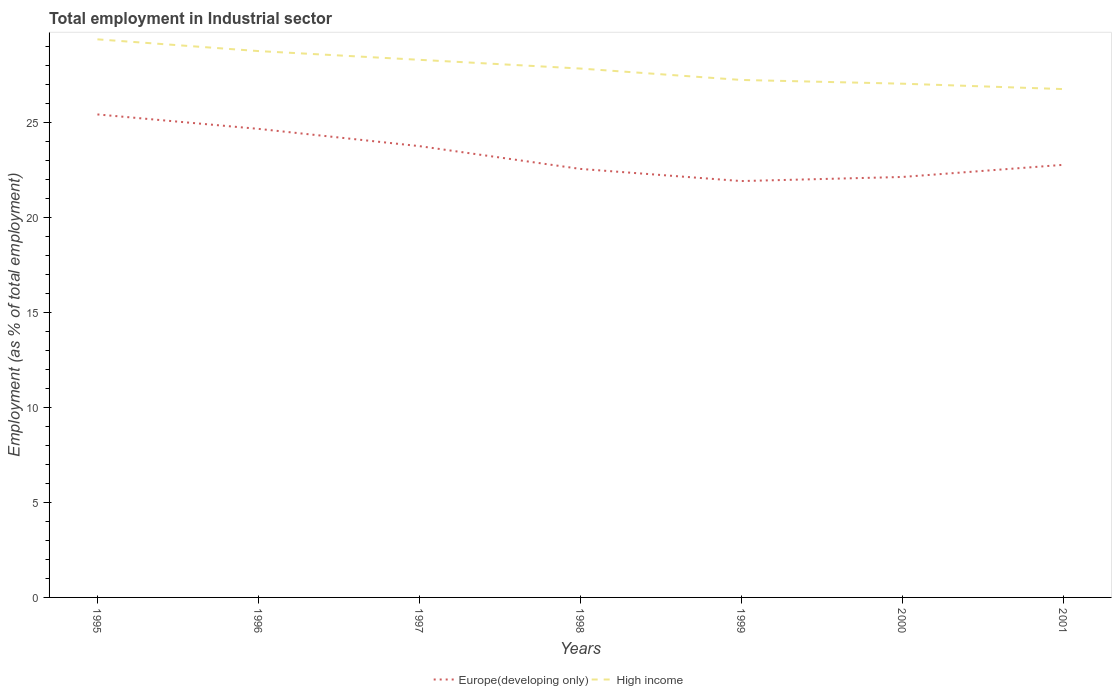Does the line corresponding to High income intersect with the line corresponding to Europe(developing only)?
Offer a very short reply. No. Is the number of lines equal to the number of legend labels?
Your response must be concise. Yes. Across all years, what is the maximum employment in industrial sector in Europe(developing only)?
Your answer should be compact. 21.93. What is the total employment in industrial sector in High income in the graph?
Offer a terse response. 0.6. What is the difference between the highest and the second highest employment in industrial sector in Europe(developing only)?
Keep it short and to the point. 3.51. What is the difference between the highest and the lowest employment in industrial sector in Europe(developing only)?
Your answer should be very brief. 3. Is the employment in industrial sector in High income strictly greater than the employment in industrial sector in Europe(developing only) over the years?
Keep it short and to the point. No. How many years are there in the graph?
Ensure brevity in your answer.  7. Are the values on the major ticks of Y-axis written in scientific E-notation?
Offer a terse response. No. Where does the legend appear in the graph?
Give a very brief answer. Bottom center. How are the legend labels stacked?
Make the answer very short. Horizontal. What is the title of the graph?
Offer a terse response. Total employment in Industrial sector. Does "New Caledonia" appear as one of the legend labels in the graph?
Your answer should be compact. No. What is the label or title of the X-axis?
Keep it short and to the point. Years. What is the label or title of the Y-axis?
Ensure brevity in your answer.  Employment (as % of total employment). What is the Employment (as % of total employment) in Europe(developing only) in 1995?
Your answer should be compact. 25.44. What is the Employment (as % of total employment) of High income in 1995?
Provide a short and direct response. 29.4. What is the Employment (as % of total employment) of Europe(developing only) in 1996?
Your answer should be very brief. 24.68. What is the Employment (as % of total employment) in High income in 1996?
Your answer should be compact. 28.78. What is the Employment (as % of total employment) of Europe(developing only) in 1997?
Ensure brevity in your answer.  23.77. What is the Employment (as % of total employment) in High income in 1997?
Your answer should be very brief. 28.32. What is the Employment (as % of total employment) in Europe(developing only) in 1998?
Offer a terse response. 22.57. What is the Employment (as % of total employment) of High income in 1998?
Your answer should be compact. 27.86. What is the Employment (as % of total employment) in Europe(developing only) in 1999?
Provide a succinct answer. 21.93. What is the Employment (as % of total employment) in High income in 1999?
Give a very brief answer. 27.26. What is the Employment (as % of total employment) of Europe(developing only) in 2000?
Provide a short and direct response. 22.15. What is the Employment (as % of total employment) of High income in 2000?
Keep it short and to the point. 27.06. What is the Employment (as % of total employment) of Europe(developing only) in 2001?
Provide a succinct answer. 22.79. What is the Employment (as % of total employment) in High income in 2001?
Make the answer very short. 26.78. Across all years, what is the maximum Employment (as % of total employment) in Europe(developing only)?
Ensure brevity in your answer.  25.44. Across all years, what is the maximum Employment (as % of total employment) of High income?
Your response must be concise. 29.4. Across all years, what is the minimum Employment (as % of total employment) in Europe(developing only)?
Offer a terse response. 21.93. Across all years, what is the minimum Employment (as % of total employment) of High income?
Your response must be concise. 26.78. What is the total Employment (as % of total employment) in Europe(developing only) in the graph?
Your answer should be compact. 163.33. What is the total Employment (as % of total employment) in High income in the graph?
Provide a short and direct response. 195.45. What is the difference between the Employment (as % of total employment) of Europe(developing only) in 1995 and that in 1996?
Give a very brief answer. 0.76. What is the difference between the Employment (as % of total employment) of High income in 1995 and that in 1996?
Your answer should be very brief. 0.62. What is the difference between the Employment (as % of total employment) of Europe(developing only) in 1995 and that in 1997?
Make the answer very short. 1.67. What is the difference between the Employment (as % of total employment) in High income in 1995 and that in 1997?
Make the answer very short. 1.08. What is the difference between the Employment (as % of total employment) of Europe(developing only) in 1995 and that in 1998?
Keep it short and to the point. 2.87. What is the difference between the Employment (as % of total employment) in High income in 1995 and that in 1998?
Ensure brevity in your answer.  1.54. What is the difference between the Employment (as % of total employment) in Europe(developing only) in 1995 and that in 1999?
Your response must be concise. 3.51. What is the difference between the Employment (as % of total employment) of High income in 1995 and that in 1999?
Your response must be concise. 2.14. What is the difference between the Employment (as % of total employment) in Europe(developing only) in 1995 and that in 2000?
Keep it short and to the point. 3.29. What is the difference between the Employment (as % of total employment) of High income in 1995 and that in 2000?
Your answer should be compact. 2.34. What is the difference between the Employment (as % of total employment) of Europe(developing only) in 1995 and that in 2001?
Provide a succinct answer. 2.66. What is the difference between the Employment (as % of total employment) in High income in 1995 and that in 2001?
Make the answer very short. 2.62. What is the difference between the Employment (as % of total employment) in Europe(developing only) in 1996 and that in 1997?
Your answer should be very brief. 0.91. What is the difference between the Employment (as % of total employment) in High income in 1996 and that in 1997?
Provide a short and direct response. 0.46. What is the difference between the Employment (as % of total employment) in Europe(developing only) in 1996 and that in 1998?
Give a very brief answer. 2.11. What is the difference between the Employment (as % of total employment) in High income in 1996 and that in 1998?
Offer a terse response. 0.92. What is the difference between the Employment (as % of total employment) of Europe(developing only) in 1996 and that in 1999?
Keep it short and to the point. 2.75. What is the difference between the Employment (as % of total employment) of High income in 1996 and that in 1999?
Offer a terse response. 1.52. What is the difference between the Employment (as % of total employment) in Europe(developing only) in 1996 and that in 2000?
Offer a very short reply. 2.53. What is the difference between the Employment (as % of total employment) in High income in 1996 and that in 2000?
Offer a very short reply. 1.72. What is the difference between the Employment (as % of total employment) in Europe(developing only) in 1996 and that in 2001?
Give a very brief answer. 1.89. What is the difference between the Employment (as % of total employment) in High income in 1996 and that in 2001?
Your response must be concise. 2. What is the difference between the Employment (as % of total employment) in High income in 1997 and that in 1998?
Offer a very short reply. 0.46. What is the difference between the Employment (as % of total employment) of Europe(developing only) in 1997 and that in 1999?
Offer a terse response. 1.84. What is the difference between the Employment (as % of total employment) of High income in 1997 and that in 1999?
Make the answer very short. 1.06. What is the difference between the Employment (as % of total employment) of Europe(developing only) in 1997 and that in 2000?
Ensure brevity in your answer.  1.62. What is the difference between the Employment (as % of total employment) of High income in 1997 and that in 2000?
Provide a short and direct response. 1.26. What is the difference between the Employment (as % of total employment) in Europe(developing only) in 1997 and that in 2001?
Make the answer very short. 0.99. What is the difference between the Employment (as % of total employment) in High income in 1997 and that in 2001?
Make the answer very short. 1.54. What is the difference between the Employment (as % of total employment) in Europe(developing only) in 1998 and that in 1999?
Your answer should be very brief. 0.64. What is the difference between the Employment (as % of total employment) of High income in 1998 and that in 1999?
Offer a very short reply. 0.6. What is the difference between the Employment (as % of total employment) in Europe(developing only) in 1998 and that in 2000?
Make the answer very short. 0.42. What is the difference between the Employment (as % of total employment) in High income in 1998 and that in 2000?
Provide a short and direct response. 0.8. What is the difference between the Employment (as % of total employment) in Europe(developing only) in 1998 and that in 2001?
Your response must be concise. -0.21. What is the difference between the Employment (as % of total employment) in High income in 1998 and that in 2001?
Your response must be concise. 1.08. What is the difference between the Employment (as % of total employment) in Europe(developing only) in 1999 and that in 2000?
Make the answer very short. -0.22. What is the difference between the Employment (as % of total employment) in High income in 1999 and that in 2000?
Your response must be concise. 0.2. What is the difference between the Employment (as % of total employment) of Europe(developing only) in 1999 and that in 2001?
Give a very brief answer. -0.85. What is the difference between the Employment (as % of total employment) of High income in 1999 and that in 2001?
Your answer should be very brief. 0.48. What is the difference between the Employment (as % of total employment) of Europe(developing only) in 2000 and that in 2001?
Offer a very short reply. -0.64. What is the difference between the Employment (as % of total employment) of High income in 2000 and that in 2001?
Offer a very short reply. 0.28. What is the difference between the Employment (as % of total employment) of Europe(developing only) in 1995 and the Employment (as % of total employment) of High income in 1996?
Ensure brevity in your answer.  -3.34. What is the difference between the Employment (as % of total employment) of Europe(developing only) in 1995 and the Employment (as % of total employment) of High income in 1997?
Your answer should be compact. -2.88. What is the difference between the Employment (as % of total employment) in Europe(developing only) in 1995 and the Employment (as % of total employment) in High income in 1998?
Provide a short and direct response. -2.42. What is the difference between the Employment (as % of total employment) of Europe(developing only) in 1995 and the Employment (as % of total employment) of High income in 1999?
Keep it short and to the point. -1.82. What is the difference between the Employment (as % of total employment) of Europe(developing only) in 1995 and the Employment (as % of total employment) of High income in 2000?
Make the answer very short. -1.62. What is the difference between the Employment (as % of total employment) in Europe(developing only) in 1995 and the Employment (as % of total employment) in High income in 2001?
Your answer should be compact. -1.33. What is the difference between the Employment (as % of total employment) of Europe(developing only) in 1996 and the Employment (as % of total employment) of High income in 1997?
Your response must be concise. -3.64. What is the difference between the Employment (as % of total employment) in Europe(developing only) in 1996 and the Employment (as % of total employment) in High income in 1998?
Provide a short and direct response. -3.18. What is the difference between the Employment (as % of total employment) in Europe(developing only) in 1996 and the Employment (as % of total employment) in High income in 1999?
Offer a very short reply. -2.58. What is the difference between the Employment (as % of total employment) in Europe(developing only) in 1996 and the Employment (as % of total employment) in High income in 2000?
Offer a terse response. -2.38. What is the difference between the Employment (as % of total employment) of Europe(developing only) in 1996 and the Employment (as % of total employment) of High income in 2001?
Provide a short and direct response. -2.1. What is the difference between the Employment (as % of total employment) in Europe(developing only) in 1997 and the Employment (as % of total employment) in High income in 1998?
Ensure brevity in your answer.  -4.09. What is the difference between the Employment (as % of total employment) of Europe(developing only) in 1997 and the Employment (as % of total employment) of High income in 1999?
Make the answer very short. -3.49. What is the difference between the Employment (as % of total employment) of Europe(developing only) in 1997 and the Employment (as % of total employment) of High income in 2000?
Offer a very short reply. -3.29. What is the difference between the Employment (as % of total employment) of Europe(developing only) in 1997 and the Employment (as % of total employment) of High income in 2001?
Offer a terse response. -3. What is the difference between the Employment (as % of total employment) in Europe(developing only) in 1998 and the Employment (as % of total employment) in High income in 1999?
Give a very brief answer. -4.69. What is the difference between the Employment (as % of total employment) in Europe(developing only) in 1998 and the Employment (as % of total employment) in High income in 2000?
Provide a succinct answer. -4.49. What is the difference between the Employment (as % of total employment) in Europe(developing only) in 1998 and the Employment (as % of total employment) in High income in 2001?
Keep it short and to the point. -4.2. What is the difference between the Employment (as % of total employment) in Europe(developing only) in 1999 and the Employment (as % of total employment) in High income in 2000?
Your answer should be very brief. -5.13. What is the difference between the Employment (as % of total employment) in Europe(developing only) in 1999 and the Employment (as % of total employment) in High income in 2001?
Provide a succinct answer. -4.84. What is the difference between the Employment (as % of total employment) in Europe(developing only) in 2000 and the Employment (as % of total employment) in High income in 2001?
Provide a short and direct response. -4.63. What is the average Employment (as % of total employment) in Europe(developing only) per year?
Keep it short and to the point. 23.33. What is the average Employment (as % of total employment) of High income per year?
Ensure brevity in your answer.  27.92. In the year 1995, what is the difference between the Employment (as % of total employment) in Europe(developing only) and Employment (as % of total employment) in High income?
Your answer should be very brief. -3.96. In the year 1996, what is the difference between the Employment (as % of total employment) of Europe(developing only) and Employment (as % of total employment) of High income?
Provide a short and direct response. -4.1. In the year 1997, what is the difference between the Employment (as % of total employment) in Europe(developing only) and Employment (as % of total employment) in High income?
Your response must be concise. -4.55. In the year 1998, what is the difference between the Employment (as % of total employment) of Europe(developing only) and Employment (as % of total employment) of High income?
Give a very brief answer. -5.29. In the year 1999, what is the difference between the Employment (as % of total employment) in Europe(developing only) and Employment (as % of total employment) in High income?
Provide a succinct answer. -5.33. In the year 2000, what is the difference between the Employment (as % of total employment) in Europe(developing only) and Employment (as % of total employment) in High income?
Offer a very short reply. -4.91. In the year 2001, what is the difference between the Employment (as % of total employment) of Europe(developing only) and Employment (as % of total employment) of High income?
Give a very brief answer. -3.99. What is the ratio of the Employment (as % of total employment) of Europe(developing only) in 1995 to that in 1996?
Your answer should be very brief. 1.03. What is the ratio of the Employment (as % of total employment) in High income in 1995 to that in 1996?
Ensure brevity in your answer.  1.02. What is the ratio of the Employment (as % of total employment) in Europe(developing only) in 1995 to that in 1997?
Offer a terse response. 1.07. What is the ratio of the Employment (as % of total employment) in High income in 1995 to that in 1997?
Give a very brief answer. 1.04. What is the ratio of the Employment (as % of total employment) in Europe(developing only) in 1995 to that in 1998?
Offer a very short reply. 1.13. What is the ratio of the Employment (as % of total employment) of High income in 1995 to that in 1998?
Keep it short and to the point. 1.06. What is the ratio of the Employment (as % of total employment) of Europe(developing only) in 1995 to that in 1999?
Make the answer very short. 1.16. What is the ratio of the Employment (as % of total employment) of High income in 1995 to that in 1999?
Ensure brevity in your answer.  1.08. What is the ratio of the Employment (as % of total employment) in Europe(developing only) in 1995 to that in 2000?
Your answer should be very brief. 1.15. What is the ratio of the Employment (as % of total employment) of High income in 1995 to that in 2000?
Offer a very short reply. 1.09. What is the ratio of the Employment (as % of total employment) in Europe(developing only) in 1995 to that in 2001?
Keep it short and to the point. 1.12. What is the ratio of the Employment (as % of total employment) in High income in 1995 to that in 2001?
Your response must be concise. 1.1. What is the ratio of the Employment (as % of total employment) in Europe(developing only) in 1996 to that in 1997?
Offer a very short reply. 1.04. What is the ratio of the Employment (as % of total employment) of High income in 1996 to that in 1997?
Your answer should be compact. 1.02. What is the ratio of the Employment (as % of total employment) of Europe(developing only) in 1996 to that in 1998?
Offer a very short reply. 1.09. What is the ratio of the Employment (as % of total employment) of High income in 1996 to that in 1998?
Your answer should be very brief. 1.03. What is the ratio of the Employment (as % of total employment) of Europe(developing only) in 1996 to that in 1999?
Offer a terse response. 1.13. What is the ratio of the Employment (as % of total employment) in High income in 1996 to that in 1999?
Provide a short and direct response. 1.06. What is the ratio of the Employment (as % of total employment) of Europe(developing only) in 1996 to that in 2000?
Offer a very short reply. 1.11. What is the ratio of the Employment (as % of total employment) in High income in 1996 to that in 2000?
Your response must be concise. 1.06. What is the ratio of the Employment (as % of total employment) in Europe(developing only) in 1996 to that in 2001?
Provide a succinct answer. 1.08. What is the ratio of the Employment (as % of total employment) of High income in 1996 to that in 2001?
Provide a succinct answer. 1.07. What is the ratio of the Employment (as % of total employment) of Europe(developing only) in 1997 to that in 1998?
Make the answer very short. 1.05. What is the ratio of the Employment (as % of total employment) in High income in 1997 to that in 1998?
Offer a terse response. 1.02. What is the ratio of the Employment (as % of total employment) in Europe(developing only) in 1997 to that in 1999?
Provide a succinct answer. 1.08. What is the ratio of the Employment (as % of total employment) of High income in 1997 to that in 1999?
Provide a succinct answer. 1.04. What is the ratio of the Employment (as % of total employment) in Europe(developing only) in 1997 to that in 2000?
Provide a short and direct response. 1.07. What is the ratio of the Employment (as % of total employment) in High income in 1997 to that in 2000?
Your response must be concise. 1.05. What is the ratio of the Employment (as % of total employment) in Europe(developing only) in 1997 to that in 2001?
Keep it short and to the point. 1.04. What is the ratio of the Employment (as % of total employment) of High income in 1997 to that in 2001?
Offer a terse response. 1.06. What is the ratio of the Employment (as % of total employment) of Europe(developing only) in 1998 to that in 1999?
Offer a terse response. 1.03. What is the ratio of the Employment (as % of total employment) of Europe(developing only) in 1998 to that in 2000?
Your response must be concise. 1.02. What is the ratio of the Employment (as % of total employment) of High income in 1998 to that in 2000?
Provide a short and direct response. 1.03. What is the ratio of the Employment (as % of total employment) of Europe(developing only) in 1998 to that in 2001?
Offer a terse response. 0.99. What is the ratio of the Employment (as % of total employment) of High income in 1998 to that in 2001?
Your response must be concise. 1.04. What is the ratio of the Employment (as % of total employment) of Europe(developing only) in 1999 to that in 2000?
Make the answer very short. 0.99. What is the ratio of the Employment (as % of total employment) of High income in 1999 to that in 2000?
Your answer should be compact. 1.01. What is the ratio of the Employment (as % of total employment) of Europe(developing only) in 1999 to that in 2001?
Keep it short and to the point. 0.96. What is the ratio of the Employment (as % of total employment) of High income in 1999 to that in 2001?
Offer a very short reply. 1.02. What is the ratio of the Employment (as % of total employment) in Europe(developing only) in 2000 to that in 2001?
Keep it short and to the point. 0.97. What is the ratio of the Employment (as % of total employment) of High income in 2000 to that in 2001?
Ensure brevity in your answer.  1.01. What is the difference between the highest and the second highest Employment (as % of total employment) in Europe(developing only)?
Your answer should be compact. 0.76. What is the difference between the highest and the second highest Employment (as % of total employment) of High income?
Your answer should be very brief. 0.62. What is the difference between the highest and the lowest Employment (as % of total employment) of Europe(developing only)?
Provide a succinct answer. 3.51. What is the difference between the highest and the lowest Employment (as % of total employment) of High income?
Offer a very short reply. 2.62. 